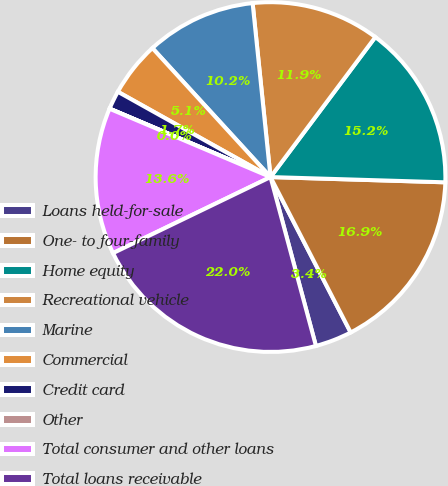Convert chart to OTSL. <chart><loc_0><loc_0><loc_500><loc_500><pie_chart><fcel>Loans held-for-sale<fcel>One- to four-family<fcel>Home equity<fcel>Recreational vehicle<fcel>Marine<fcel>Commercial<fcel>Credit card<fcel>Other<fcel>Total consumer and other loans<fcel>Total loans receivable<nl><fcel>3.4%<fcel>16.94%<fcel>15.25%<fcel>11.86%<fcel>10.17%<fcel>5.09%<fcel>1.71%<fcel>0.01%<fcel>13.55%<fcel>22.02%<nl></chart> 